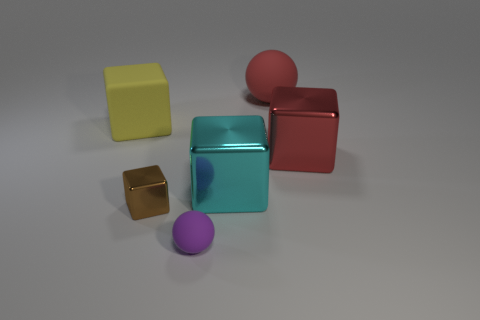Are there any other things that are the same size as the yellow matte thing?
Give a very brief answer. Yes. There is a sphere behind the tiny object behind the small purple sphere; is there a brown cube behind it?
Make the answer very short. No. Is the color of the small metallic cube the same as the big object to the left of the small matte object?
Offer a terse response. No. There is a ball left of the matte thing that is behind the large block to the left of the small ball; what is it made of?
Give a very brief answer. Rubber. What shape is the large thing that is left of the tiny ball?
Keep it short and to the point. Cube. What size is the red thing that is made of the same material as the yellow cube?
Your answer should be compact. Large. What number of yellow rubber things have the same shape as the tiny metal thing?
Your response must be concise. 1. There is a big metallic cube behind the large cyan object; does it have the same color as the rubber block?
Your answer should be compact. No. There is a large rubber thing that is left of the small thing that is behind the tiny purple sphere; what number of large objects are behind it?
Give a very brief answer. 1. What number of rubber things are on the right side of the small brown metal object and behind the brown cube?
Provide a short and direct response. 1. 